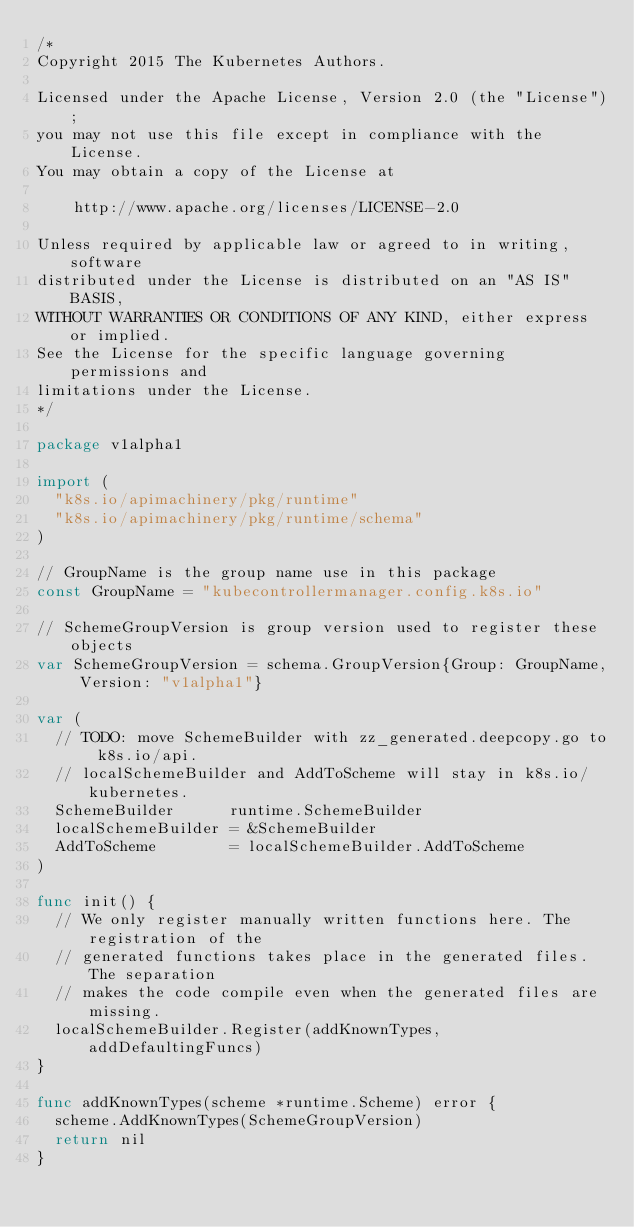<code> <loc_0><loc_0><loc_500><loc_500><_Go_>/*
Copyright 2015 The Kubernetes Authors.

Licensed under the Apache License, Version 2.0 (the "License");
you may not use this file except in compliance with the License.
You may obtain a copy of the License at

    http://www.apache.org/licenses/LICENSE-2.0

Unless required by applicable law or agreed to in writing, software
distributed under the License is distributed on an "AS IS" BASIS,
WITHOUT WARRANTIES OR CONDITIONS OF ANY KIND, either express or implied.
See the License for the specific language governing permissions and
limitations under the License.
*/

package v1alpha1

import (
	"k8s.io/apimachinery/pkg/runtime"
	"k8s.io/apimachinery/pkg/runtime/schema"
)

// GroupName is the group name use in this package
const GroupName = "kubecontrollermanager.config.k8s.io"

// SchemeGroupVersion is group version used to register these objects
var SchemeGroupVersion = schema.GroupVersion{Group: GroupName, Version: "v1alpha1"}

var (
	// TODO: move SchemeBuilder with zz_generated.deepcopy.go to k8s.io/api.
	// localSchemeBuilder and AddToScheme will stay in k8s.io/kubernetes.
	SchemeBuilder      runtime.SchemeBuilder
	localSchemeBuilder = &SchemeBuilder
	AddToScheme        = localSchemeBuilder.AddToScheme
)

func init() {
	// We only register manually written functions here. The registration of the
	// generated functions takes place in the generated files. The separation
	// makes the code compile even when the generated files are missing.
	localSchemeBuilder.Register(addKnownTypes, addDefaultingFuncs)
}

func addKnownTypes(scheme *runtime.Scheme) error {
	scheme.AddKnownTypes(SchemeGroupVersion)
	return nil
}
</code> 